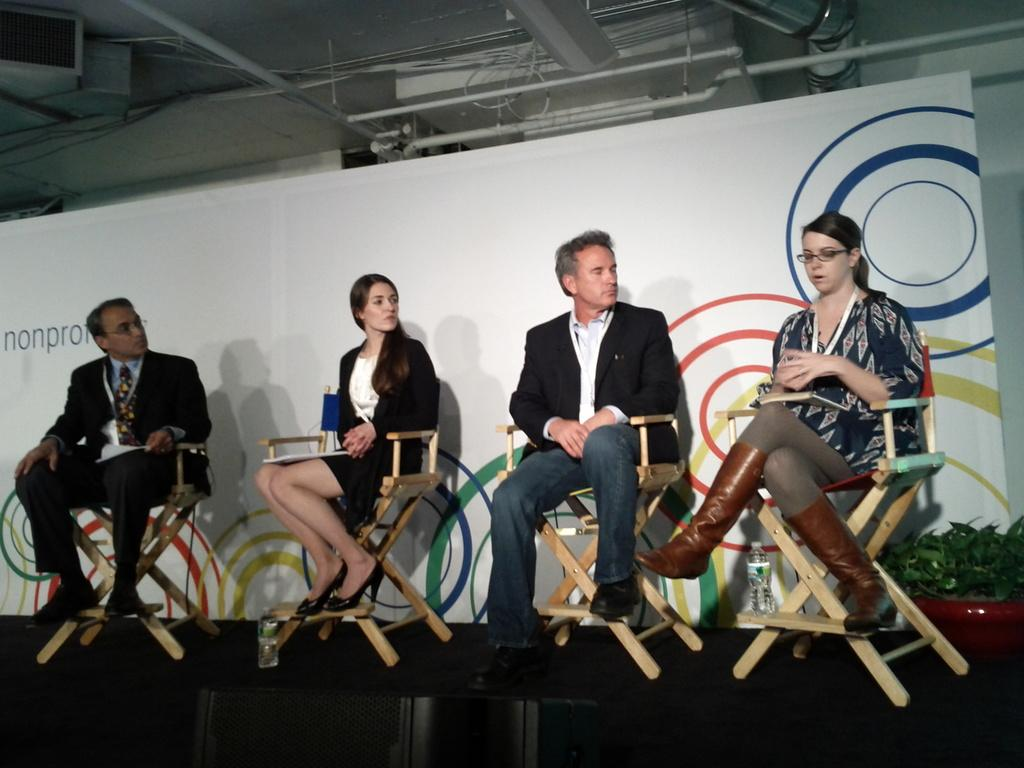How many people are in the image? There are four people in the image, two men and two women. What are the people doing in the image? The people are sitting on chairs. What can be seen behind the people? There is a banner behind the people. What type of plant is near the people? There is a house plant near the people. What else is near the people? There are bottles near the people. What type of nerve can be seen in the image? There is no nerve present in the image. What type of voyage are the people embarking on in the image? There is no voyage depicted in the image; the people are sitting on chairs. 